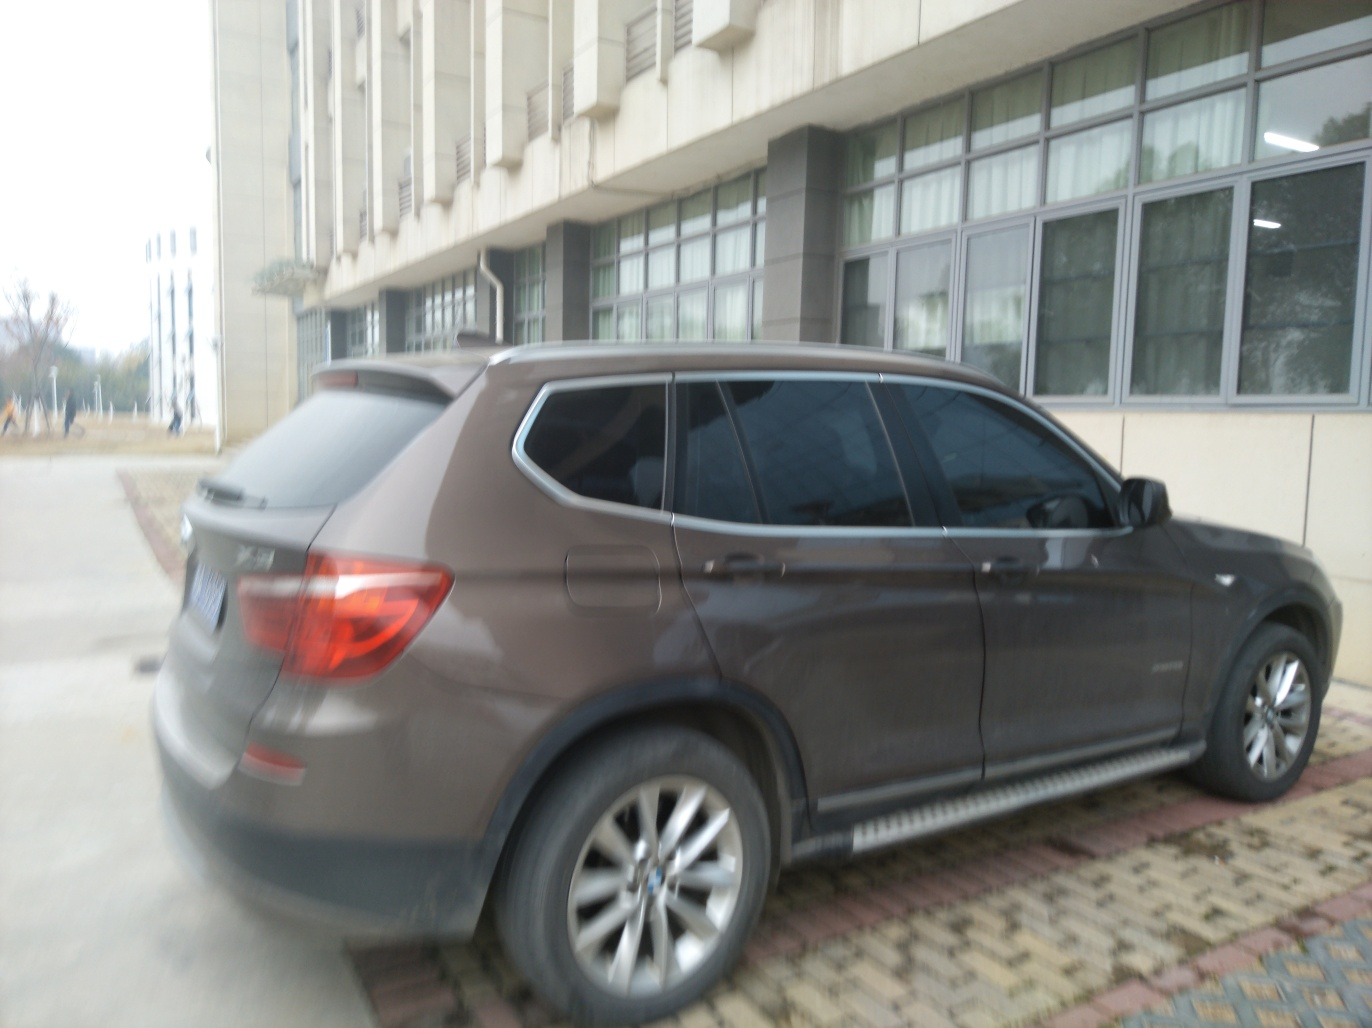What can you infer about the maintenance of the vehicle? The vehicle appears to be well-maintained with no immediate signs of damage or neglect. The body of the car shows a consistent sheen, suggesting it is relatively clean, although the blurry image might hide minor imperfections. Overall, the vehicle presents an image of being cared for, again with the caveat that some details are obscured. Does the setting give any clues about the location? The building behind the car has a functional design, with large windows and an industrial feel which might hint at an educational or government establishment. The paver block ground suggests an organized urban area. Yet, without distinctive architectural elements or signs, the precise location remains ambiguous. 